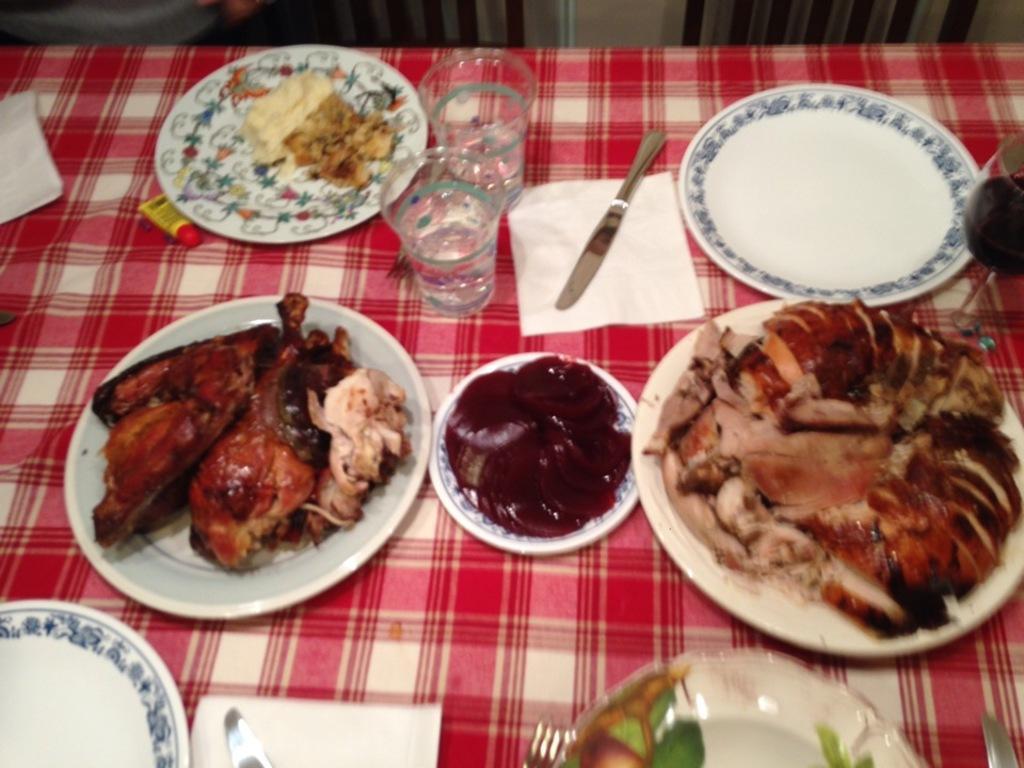Describe this image in one or two sentences. This image consists of a table covered with a red cloth, on which there are many plates. And food is kept along with knife and glasses. 